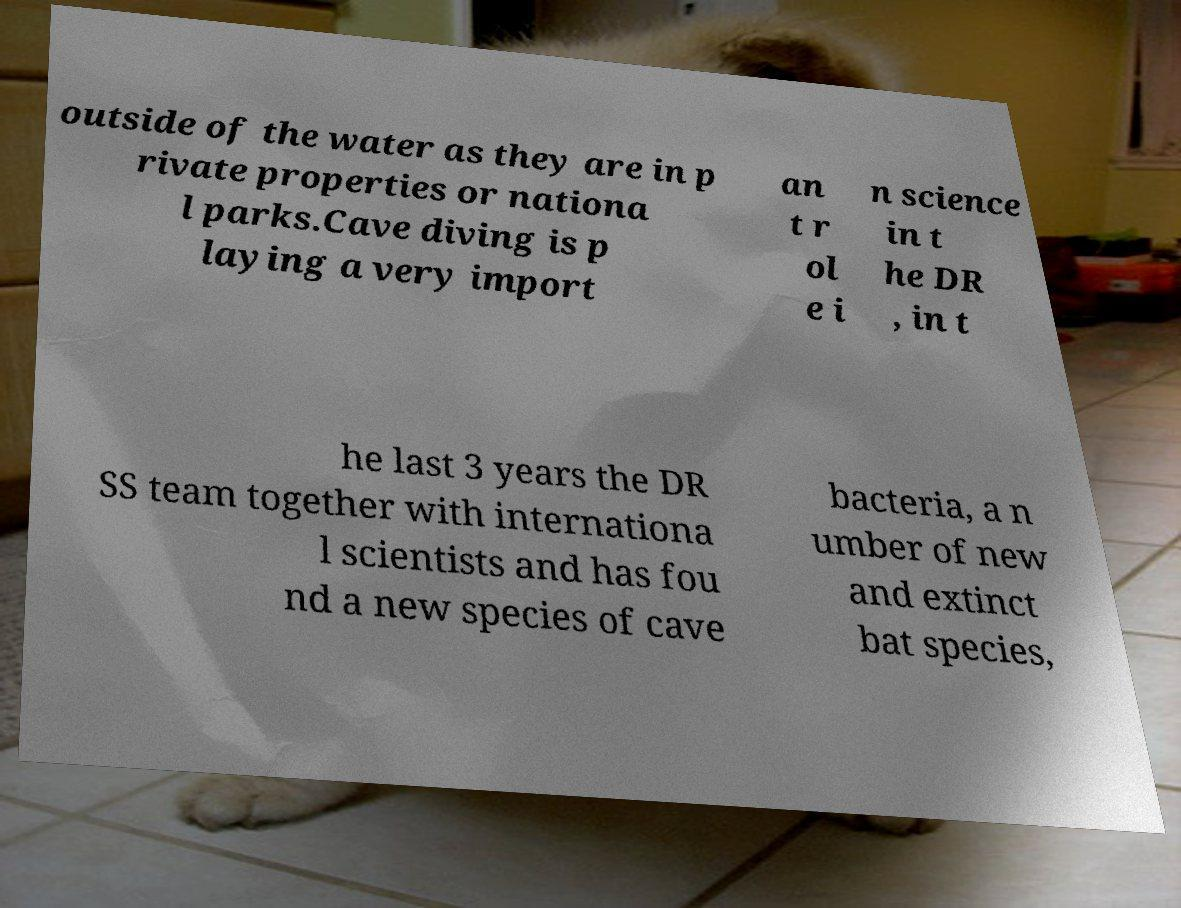Please identify and transcribe the text found in this image. outside of the water as they are in p rivate properties or nationa l parks.Cave diving is p laying a very import an t r ol e i n science in t he DR , in t he last 3 years the DR SS team together with internationa l scientists and has fou nd a new species of cave bacteria, a n umber of new and extinct bat species, 